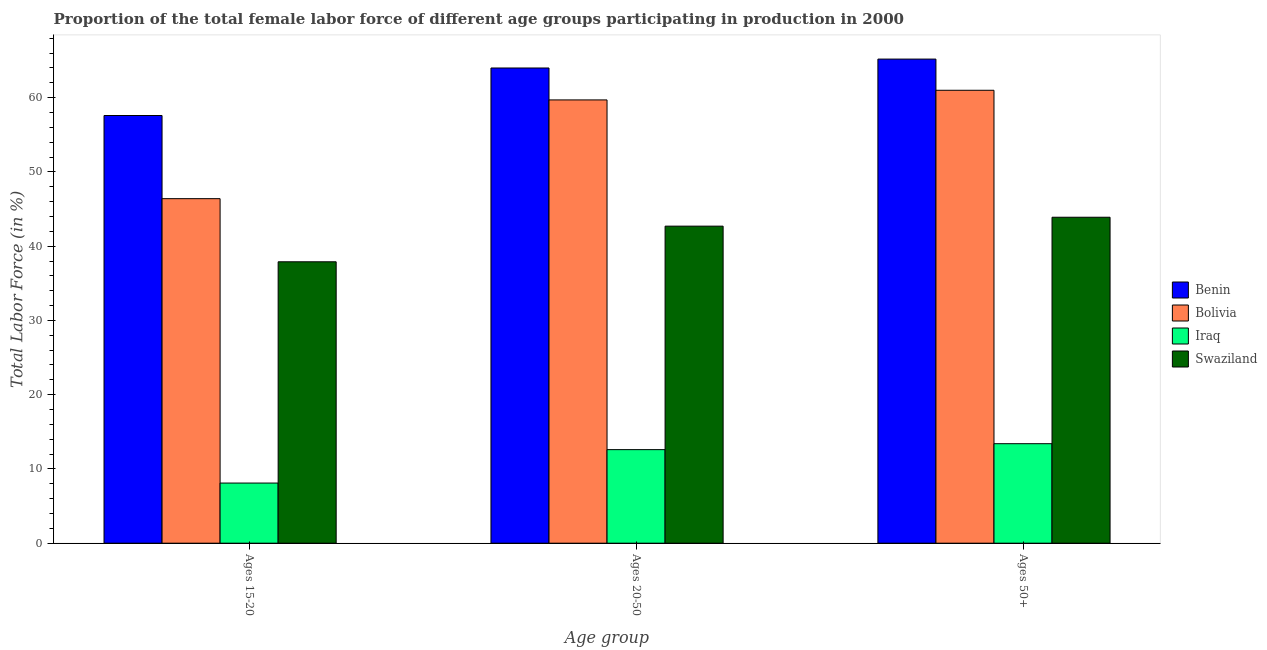How many different coloured bars are there?
Keep it short and to the point. 4. Are the number of bars on each tick of the X-axis equal?
Keep it short and to the point. Yes. How many bars are there on the 2nd tick from the left?
Provide a short and direct response. 4. What is the label of the 2nd group of bars from the left?
Offer a very short reply. Ages 20-50. What is the percentage of female labor force within the age group 20-50 in Bolivia?
Provide a short and direct response. 59.7. Across all countries, what is the maximum percentage of female labor force within the age group 15-20?
Your answer should be compact. 57.6. Across all countries, what is the minimum percentage of female labor force within the age group 20-50?
Offer a terse response. 12.6. In which country was the percentage of female labor force above age 50 maximum?
Give a very brief answer. Benin. In which country was the percentage of female labor force within the age group 15-20 minimum?
Your answer should be very brief. Iraq. What is the total percentage of female labor force above age 50 in the graph?
Your answer should be compact. 183.5. What is the difference between the percentage of female labor force above age 50 in Swaziland and that in Bolivia?
Give a very brief answer. -17.1. What is the difference between the percentage of female labor force above age 50 in Iraq and the percentage of female labor force within the age group 15-20 in Swaziland?
Provide a short and direct response. -24.5. What is the average percentage of female labor force within the age group 20-50 per country?
Provide a succinct answer. 44.75. What is the difference between the percentage of female labor force within the age group 20-50 and percentage of female labor force above age 50 in Swaziland?
Your response must be concise. -1.2. What is the ratio of the percentage of female labor force within the age group 20-50 in Benin to that in Bolivia?
Your answer should be very brief. 1.07. Is the percentage of female labor force above age 50 in Bolivia less than that in Benin?
Provide a short and direct response. Yes. What is the difference between the highest and the second highest percentage of female labor force within the age group 15-20?
Ensure brevity in your answer.  11.2. What is the difference between the highest and the lowest percentage of female labor force within the age group 20-50?
Keep it short and to the point. 51.4. What does the 3rd bar from the left in Ages 15-20 represents?
Offer a terse response. Iraq. What does the 1st bar from the right in Ages 15-20 represents?
Provide a succinct answer. Swaziland. Is it the case that in every country, the sum of the percentage of female labor force within the age group 15-20 and percentage of female labor force within the age group 20-50 is greater than the percentage of female labor force above age 50?
Your answer should be very brief. Yes. Are all the bars in the graph horizontal?
Give a very brief answer. No. How many countries are there in the graph?
Provide a succinct answer. 4. What is the difference between two consecutive major ticks on the Y-axis?
Make the answer very short. 10. Does the graph contain grids?
Provide a short and direct response. No. Where does the legend appear in the graph?
Make the answer very short. Center right. How many legend labels are there?
Give a very brief answer. 4. How are the legend labels stacked?
Provide a succinct answer. Vertical. What is the title of the graph?
Keep it short and to the point. Proportion of the total female labor force of different age groups participating in production in 2000. Does "Micronesia" appear as one of the legend labels in the graph?
Make the answer very short. No. What is the label or title of the X-axis?
Your answer should be compact. Age group. What is the Total Labor Force (in %) of Benin in Ages 15-20?
Offer a terse response. 57.6. What is the Total Labor Force (in %) in Bolivia in Ages 15-20?
Offer a very short reply. 46.4. What is the Total Labor Force (in %) in Iraq in Ages 15-20?
Keep it short and to the point. 8.1. What is the Total Labor Force (in %) of Swaziland in Ages 15-20?
Give a very brief answer. 37.9. What is the Total Labor Force (in %) of Bolivia in Ages 20-50?
Your answer should be compact. 59.7. What is the Total Labor Force (in %) of Iraq in Ages 20-50?
Keep it short and to the point. 12.6. What is the Total Labor Force (in %) in Swaziland in Ages 20-50?
Your response must be concise. 42.7. What is the Total Labor Force (in %) in Benin in Ages 50+?
Your response must be concise. 65.2. What is the Total Labor Force (in %) in Iraq in Ages 50+?
Offer a terse response. 13.4. What is the Total Labor Force (in %) of Swaziland in Ages 50+?
Give a very brief answer. 43.9. Across all Age group, what is the maximum Total Labor Force (in %) in Benin?
Provide a succinct answer. 65.2. Across all Age group, what is the maximum Total Labor Force (in %) of Iraq?
Provide a succinct answer. 13.4. Across all Age group, what is the maximum Total Labor Force (in %) of Swaziland?
Offer a terse response. 43.9. Across all Age group, what is the minimum Total Labor Force (in %) in Benin?
Make the answer very short. 57.6. Across all Age group, what is the minimum Total Labor Force (in %) of Bolivia?
Your answer should be very brief. 46.4. Across all Age group, what is the minimum Total Labor Force (in %) of Iraq?
Give a very brief answer. 8.1. Across all Age group, what is the minimum Total Labor Force (in %) in Swaziland?
Offer a very short reply. 37.9. What is the total Total Labor Force (in %) of Benin in the graph?
Offer a very short reply. 186.8. What is the total Total Labor Force (in %) in Bolivia in the graph?
Ensure brevity in your answer.  167.1. What is the total Total Labor Force (in %) in Iraq in the graph?
Provide a short and direct response. 34.1. What is the total Total Labor Force (in %) in Swaziland in the graph?
Give a very brief answer. 124.5. What is the difference between the Total Labor Force (in %) in Benin in Ages 15-20 and that in Ages 20-50?
Give a very brief answer. -6.4. What is the difference between the Total Labor Force (in %) in Benin in Ages 15-20 and that in Ages 50+?
Ensure brevity in your answer.  -7.6. What is the difference between the Total Labor Force (in %) in Bolivia in Ages 15-20 and that in Ages 50+?
Your answer should be compact. -14.6. What is the difference between the Total Labor Force (in %) in Swaziland in Ages 20-50 and that in Ages 50+?
Offer a very short reply. -1.2. What is the difference between the Total Labor Force (in %) in Benin in Ages 15-20 and the Total Labor Force (in %) in Swaziland in Ages 20-50?
Ensure brevity in your answer.  14.9. What is the difference between the Total Labor Force (in %) in Bolivia in Ages 15-20 and the Total Labor Force (in %) in Iraq in Ages 20-50?
Keep it short and to the point. 33.8. What is the difference between the Total Labor Force (in %) in Bolivia in Ages 15-20 and the Total Labor Force (in %) in Swaziland in Ages 20-50?
Keep it short and to the point. 3.7. What is the difference between the Total Labor Force (in %) in Iraq in Ages 15-20 and the Total Labor Force (in %) in Swaziland in Ages 20-50?
Your answer should be very brief. -34.6. What is the difference between the Total Labor Force (in %) in Benin in Ages 15-20 and the Total Labor Force (in %) in Bolivia in Ages 50+?
Give a very brief answer. -3.4. What is the difference between the Total Labor Force (in %) in Benin in Ages 15-20 and the Total Labor Force (in %) in Iraq in Ages 50+?
Offer a very short reply. 44.2. What is the difference between the Total Labor Force (in %) in Iraq in Ages 15-20 and the Total Labor Force (in %) in Swaziland in Ages 50+?
Your answer should be very brief. -35.8. What is the difference between the Total Labor Force (in %) of Benin in Ages 20-50 and the Total Labor Force (in %) of Bolivia in Ages 50+?
Make the answer very short. 3. What is the difference between the Total Labor Force (in %) in Benin in Ages 20-50 and the Total Labor Force (in %) in Iraq in Ages 50+?
Offer a terse response. 50.6. What is the difference between the Total Labor Force (in %) of Benin in Ages 20-50 and the Total Labor Force (in %) of Swaziland in Ages 50+?
Your answer should be very brief. 20.1. What is the difference between the Total Labor Force (in %) of Bolivia in Ages 20-50 and the Total Labor Force (in %) of Iraq in Ages 50+?
Your answer should be very brief. 46.3. What is the difference between the Total Labor Force (in %) of Iraq in Ages 20-50 and the Total Labor Force (in %) of Swaziland in Ages 50+?
Make the answer very short. -31.3. What is the average Total Labor Force (in %) in Benin per Age group?
Make the answer very short. 62.27. What is the average Total Labor Force (in %) of Bolivia per Age group?
Keep it short and to the point. 55.7. What is the average Total Labor Force (in %) in Iraq per Age group?
Provide a succinct answer. 11.37. What is the average Total Labor Force (in %) in Swaziland per Age group?
Make the answer very short. 41.5. What is the difference between the Total Labor Force (in %) of Benin and Total Labor Force (in %) of Iraq in Ages 15-20?
Provide a succinct answer. 49.5. What is the difference between the Total Labor Force (in %) of Bolivia and Total Labor Force (in %) of Iraq in Ages 15-20?
Provide a short and direct response. 38.3. What is the difference between the Total Labor Force (in %) in Bolivia and Total Labor Force (in %) in Swaziland in Ages 15-20?
Keep it short and to the point. 8.5. What is the difference between the Total Labor Force (in %) of Iraq and Total Labor Force (in %) of Swaziland in Ages 15-20?
Your response must be concise. -29.8. What is the difference between the Total Labor Force (in %) of Benin and Total Labor Force (in %) of Bolivia in Ages 20-50?
Offer a very short reply. 4.3. What is the difference between the Total Labor Force (in %) of Benin and Total Labor Force (in %) of Iraq in Ages 20-50?
Offer a terse response. 51.4. What is the difference between the Total Labor Force (in %) of Benin and Total Labor Force (in %) of Swaziland in Ages 20-50?
Offer a very short reply. 21.3. What is the difference between the Total Labor Force (in %) of Bolivia and Total Labor Force (in %) of Iraq in Ages 20-50?
Provide a short and direct response. 47.1. What is the difference between the Total Labor Force (in %) of Iraq and Total Labor Force (in %) of Swaziland in Ages 20-50?
Provide a short and direct response. -30.1. What is the difference between the Total Labor Force (in %) in Benin and Total Labor Force (in %) in Bolivia in Ages 50+?
Offer a very short reply. 4.2. What is the difference between the Total Labor Force (in %) of Benin and Total Labor Force (in %) of Iraq in Ages 50+?
Ensure brevity in your answer.  51.8. What is the difference between the Total Labor Force (in %) in Benin and Total Labor Force (in %) in Swaziland in Ages 50+?
Offer a very short reply. 21.3. What is the difference between the Total Labor Force (in %) of Bolivia and Total Labor Force (in %) of Iraq in Ages 50+?
Make the answer very short. 47.6. What is the difference between the Total Labor Force (in %) of Iraq and Total Labor Force (in %) of Swaziland in Ages 50+?
Your answer should be compact. -30.5. What is the ratio of the Total Labor Force (in %) of Benin in Ages 15-20 to that in Ages 20-50?
Your answer should be compact. 0.9. What is the ratio of the Total Labor Force (in %) of Bolivia in Ages 15-20 to that in Ages 20-50?
Your response must be concise. 0.78. What is the ratio of the Total Labor Force (in %) in Iraq in Ages 15-20 to that in Ages 20-50?
Your response must be concise. 0.64. What is the ratio of the Total Labor Force (in %) of Swaziland in Ages 15-20 to that in Ages 20-50?
Your response must be concise. 0.89. What is the ratio of the Total Labor Force (in %) in Benin in Ages 15-20 to that in Ages 50+?
Offer a terse response. 0.88. What is the ratio of the Total Labor Force (in %) of Bolivia in Ages 15-20 to that in Ages 50+?
Ensure brevity in your answer.  0.76. What is the ratio of the Total Labor Force (in %) of Iraq in Ages 15-20 to that in Ages 50+?
Give a very brief answer. 0.6. What is the ratio of the Total Labor Force (in %) in Swaziland in Ages 15-20 to that in Ages 50+?
Your response must be concise. 0.86. What is the ratio of the Total Labor Force (in %) in Benin in Ages 20-50 to that in Ages 50+?
Offer a very short reply. 0.98. What is the ratio of the Total Labor Force (in %) of Bolivia in Ages 20-50 to that in Ages 50+?
Offer a very short reply. 0.98. What is the ratio of the Total Labor Force (in %) of Iraq in Ages 20-50 to that in Ages 50+?
Offer a terse response. 0.94. What is the ratio of the Total Labor Force (in %) of Swaziland in Ages 20-50 to that in Ages 50+?
Give a very brief answer. 0.97. What is the difference between the highest and the second highest Total Labor Force (in %) of Benin?
Make the answer very short. 1.2. What is the difference between the highest and the second highest Total Labor Force (in %) of Bolivia?
Keep it short and to the point. 1.3. What is the difference between the highest and the lowest Total Labor Force (in %) in Benin?
Offer a very short reply. 7.6. What is the difference between the highest and the lowest Total Labor Force (in %) in Bolivia?
Your answer should be compact. 14.6. 